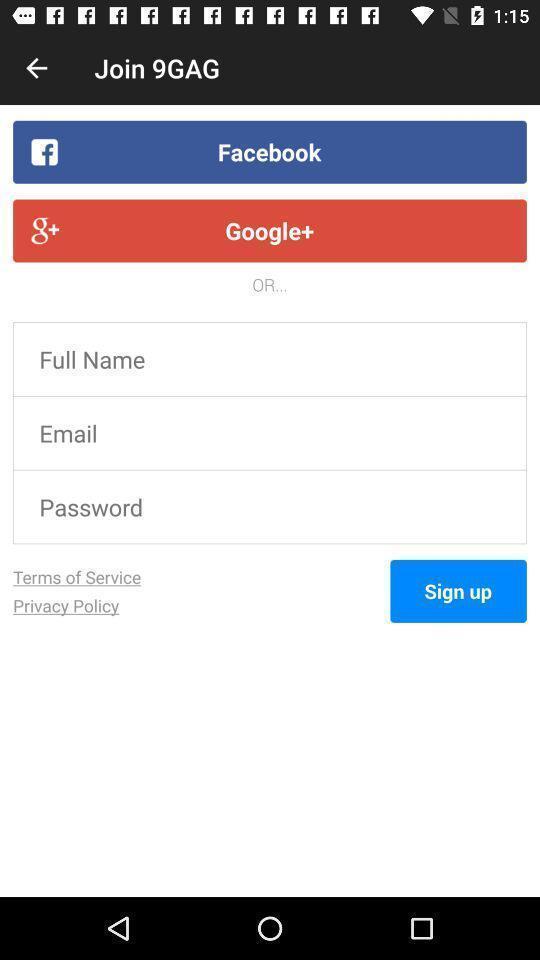Tell me what you see in this picture. Sign up page with some options. 